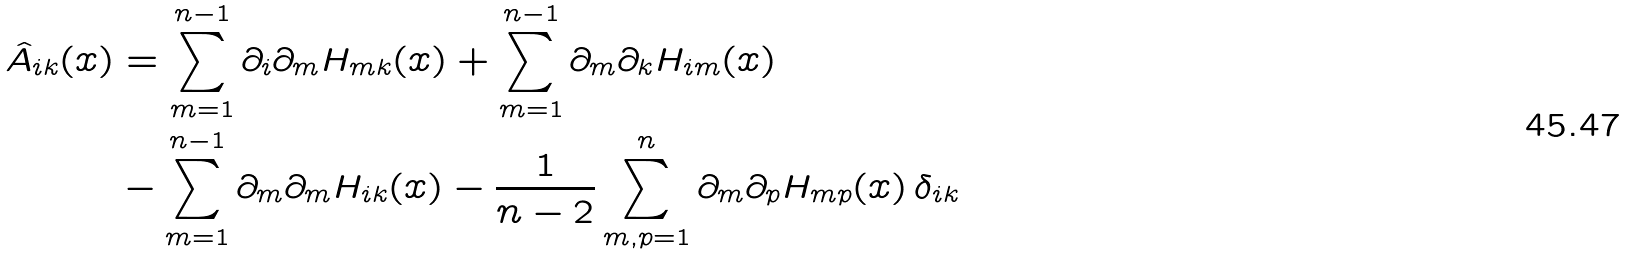<formula> <loc_0><loc_0><loc_500><loc_500>\hat { A } _ { i k } ( x ) & = \sum _ { m = 1 } ^ { n - 1 } \partial _ { i } \partial _ { m } H _ { m k } ( x ) + \sum _ { m = 1 } ^ { n - 1 } \partial _ { m } \partial _ { k } H _ { i m } ( x ) \\ & - \sum _ { m = 1 } ^ { n - 1 } \partial _ { m } \partial _ { m } H _ { i k } ( x ) - \frac { 1 } { n - 2 } \sum _ { m , p = 1 } ^ { n } \partial _ { m } \partial _ { p } H _ { m p } ( x ) \, \delta _ { i k }</formula> 